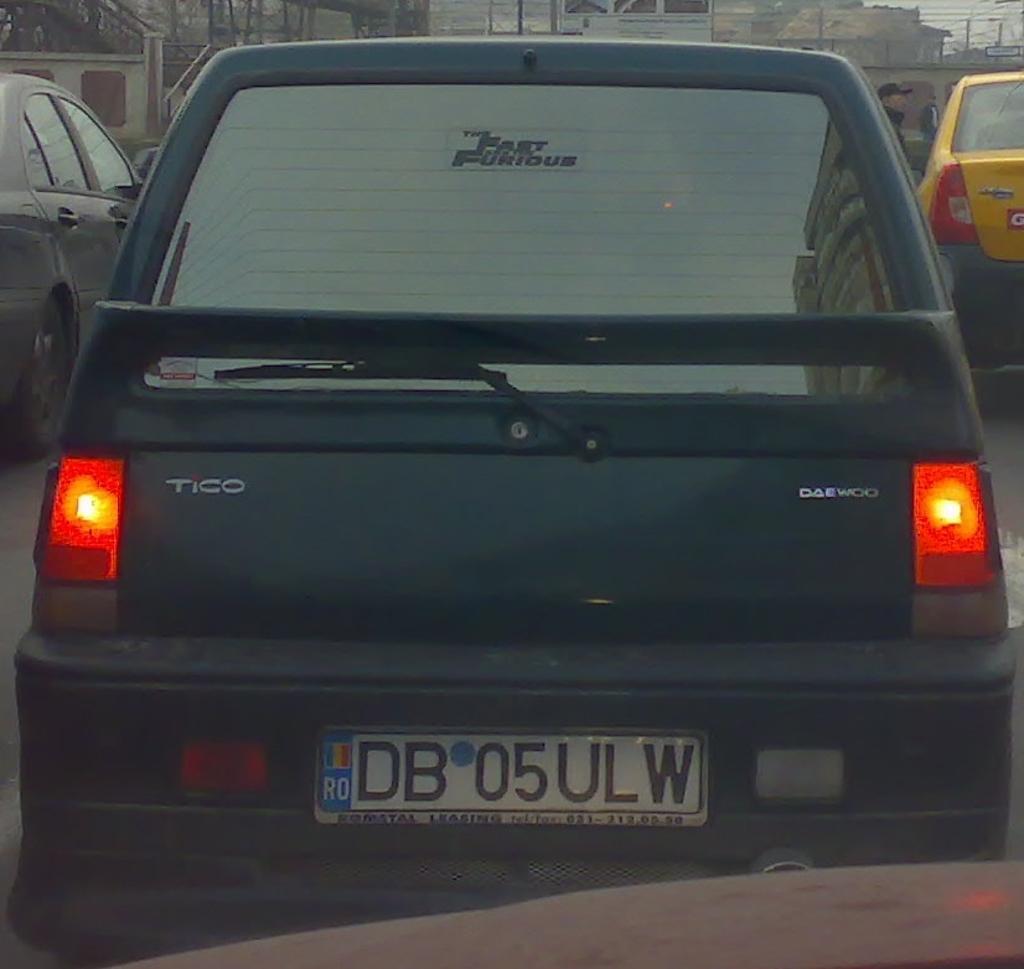Can you describe this image briefly? In this image we can see there are few cars on the road and there is a person. In the background there are buildings. 